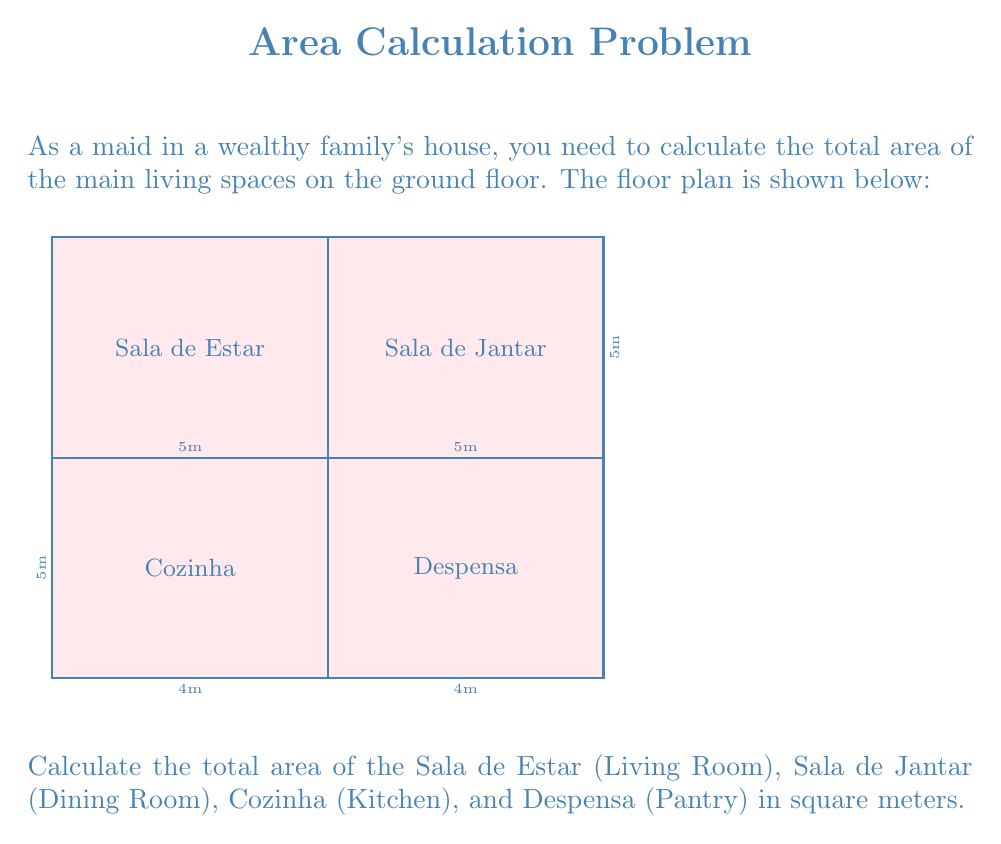Solve this math problem. To calculate the total area, we need to find the area of each room and then sum them up:

1. Sala de Estar (Living Room):
   Area = length × width = $5\text{ m} \times 5\text{ m} = 25\text{ m}^2$

2. Sala de Jantar (Dining Room):
   Area = length × width = $5\text{ m} \times 5\text{ m} = 25\text{ m}^2$

3. Cozinha (Kitchen):
   Area = length × width = $5\text{ m} \times 4\text{ m} = 20\text{ m}^2$

4. Despensa (Pantry):
   Area = length × width = $5\text{ m} \times 4\text{ m} = 20\text{ m}^2$

Now, we sum up all the areas:

Total Area = $25\text{ m}^2 + 25\text{ m}^2 + 20\text{ m}^2 + 20\text{ m}^2 = 90\text{ m}^2$

Therefore, the total area of the main living spaces on the ground floor is $90\text{ m}^2$.
Answer: $90\text{ m}^2$ 